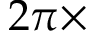Convert formula to latex. <formula><loc_0><loc_0><loc_500><loc_500>2 \pi \times</formula> 